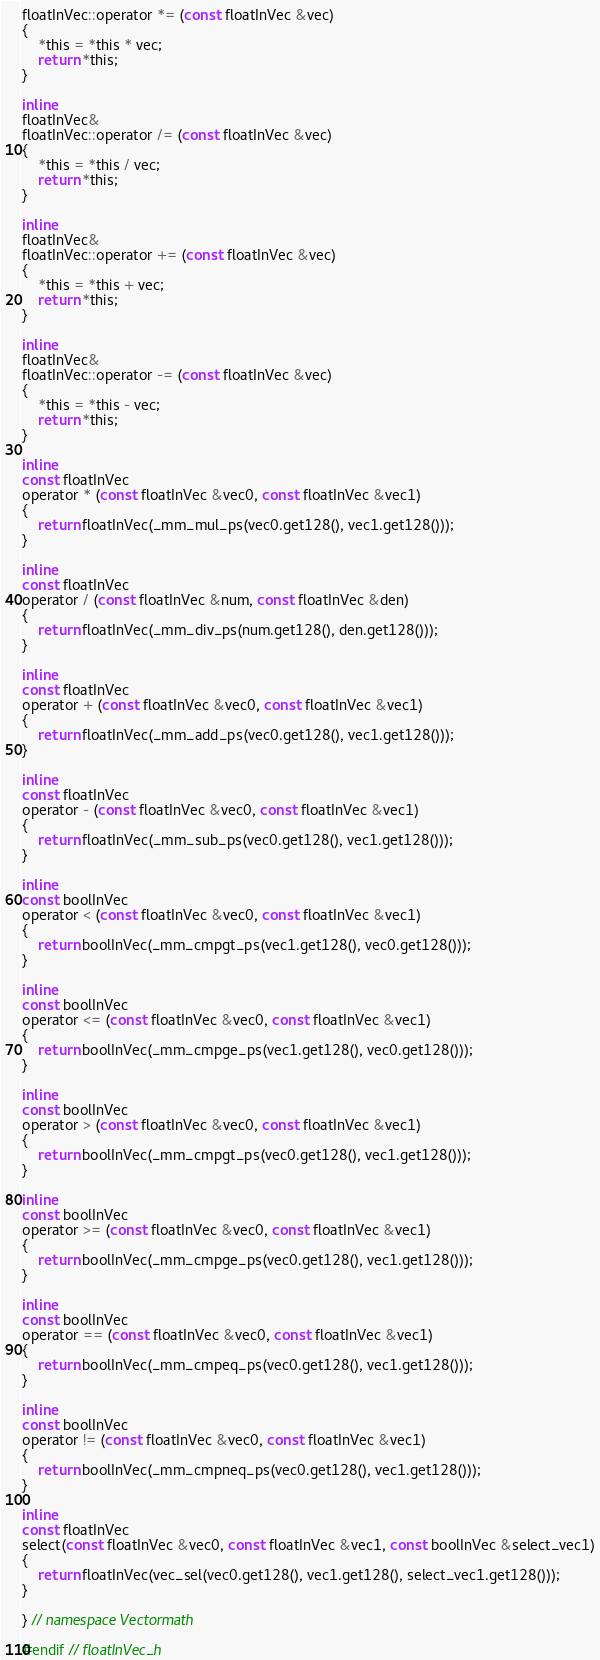Convert code to text. <code><loc_0><loc_0><loc_500><loc_500><_C_>floatInVec::operator *= (const floatInVec &vec)
{
    *this = *this * vec;
    return *this;
}

inline
floatInVec&
floatInVec::operator /= (const floatInVec &vec)
{
    *this = *this / vec;
    return *this;
}

inline
floatInVec&
floatInVec::operator += (const floatInVec &vec)
{
    *this = *this + vec;
    return *this;
}

inline
floatInVec&
floatInVec::operator -= (const floatInVec &vec)
{
    *this = *this - vec;
    return *this;
}

inline
const floatInVec
operator * (const floatInVec &vec0, const floatInVec &vec1)
{
    return floatInVec(_mm_mul_ps(vec0.get128(), vec1.get128()));
}

inline
const floatInVec
operator / (const floatInVec &num, const floatInVec &den)
{
    return floatInVec(_mm_div_ps(num.get128(), den.get128()));
}

inline
const floatInVec
operator + (const floatInVec &vec0, const floatInVec &vec1)
{
    return floatInVec(_mm_add_ps(vec0.get128(), vec1.get128()));
}

inline
const floatInVec
operator - (const floatInVec &vec0, const floatInVec &vec1)
{
    return floatInVec(_mm_sub_ps(vec0.get128(), vec1.get128()));
}

inline
const boolInVec
operator < (const floatInVec &vec0, const floatInVec &vec1)
{
    return boolInVec(_mm_cmpgt_ps(vec1.get128(), vec0.get128()));
}

inline
const boolInVec
operator <= (const floatInVec &vec0, const floatInVec &vec1)
{
    return boolInVec(_mm_cmpge_ps(vec1.get128(), vec0.get128()));
}

inline
const boolInVec
operator > (const floatInVec &vec0, const floatInVec &vec1)
{
    return boolInVec(_mm_cmpgt_ps(vec0.get128(), vec1.get128()));
}

inline
const boolInVec
operator >= (const floatInVec &vec0, const floatInVec &vec1)
{
    return boolInVec(_mm_cmpge_ps(vec0.get128(), vec1.get128()));
}

inline
const boolInVec
operator == (const floatInVec &vec0, const floatInVec &vec1)
{
    return boolInVec(_mm_cmpeq_ps(vec0.get128(), vec1.get128()));
}

inline
const boolInVec
operator != (const floatInVec &vec0, const floatInVec &vec1)
{
    return boolInVec(_mm_cmpneq_ps(vec0.get128(), vec1.get128()));
}
    
inline
const floatInVec
select(const floatInVec &vec0, const floatInVec &vec1, const boolInVec &select_vec1)
{
    return floatInVec(vec_sel(vec0.get128(), vec1.get128(), select_vec1.get128()));
}

} // namespace Vectormath

#endif // floatInVec_h
</code> 